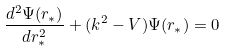<formula> <loc_0><loc_0><loc_500><loc_500>\frac { d ^ { 2 } \Psi ( r _ { * } ) } { d r _ { * } ^ { 2 } } + ( k ^ { 2 } - V ) \Psi ( r _ { * } ) = 0</formula> 